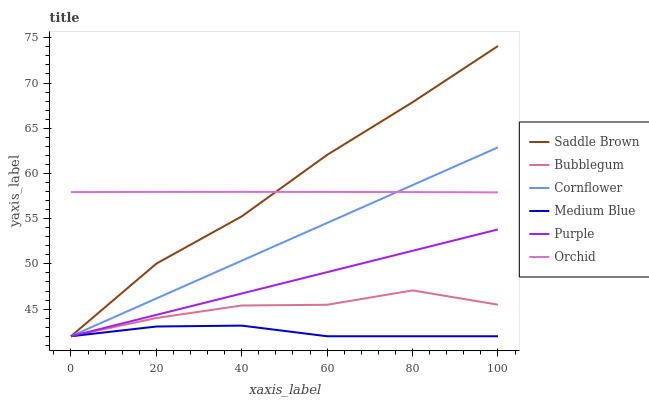Does Purple have the minimum area under the curve?
Answer yes or no. No. Does Purple have the maximum area under the curve?
Answer yes or no. No. Is Purple the smoothest?
Answer yes or no. No. Is Purple the roughest?
Answer yes or no. No. Does Orchid have the lowest value?
Answer yes or no. No. Does Purple have the highest value?
Answer yes or no. No. Is Medium Blue less than Orchid?
Answer yes or no. Yes. Is Orchid greater than Medium Blue?
Answer yes or no. Yes. Does Medium Blue intersect Orchid?
Answer yes or no. No. 